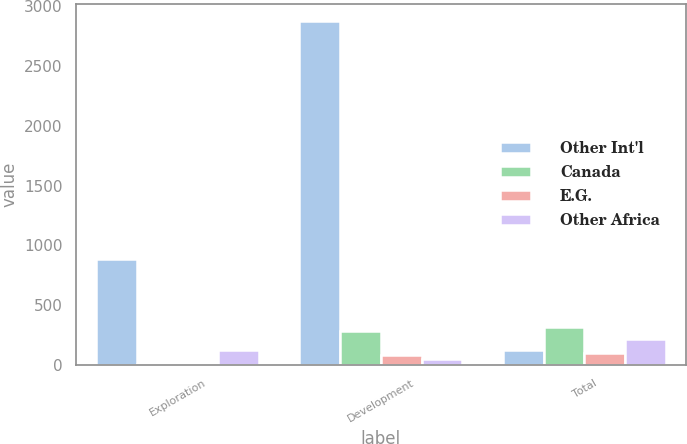Convert chart. <chart><loc_0><loc_0><loc_500><loc_500><stacked_bar_chart><ecel><fcel>Exploration<fcel>Development<fcel>Total<nl><fcel>Other Int'l<fcel>885<fcel>2876<fcel>124<nl><fcel>Canada<fcel>9<fcel>280<fcel>319<nl><fcel>E.G.<fcel>4<fcel>84<fcel>97<nl><fcel>Other Africa<fcel>124<fcel>46<fcel>214<nl></chart> 